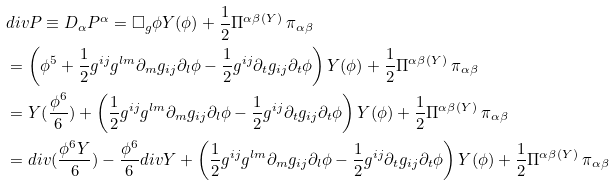<formula> <loc_0><loc_0><loc_500><loc_500>& d i v P \equiv D _ { \alpha } P ^ { \alpha } = \Box _ { g } \phi Y ( \phi ) + \frac { 1 } { 2 } \Pi ^ { \alpha \beta } { ^ { ( Y ) } \, \pi } _ { \alpha \beta } \\ & = \left ( \phi ^ { 5 } + \frac { 1 } { 2 } g ^ { i j } g ^ { l m } \partial _ { m } g _ { i j } \partial _ { l } \phi - \frac { 1 } { 2 } g ^ { i j } \partial _ { t } g _ { i j } \partial _ { t } \phi \right ) Y ( \phi ) + \frac { 1 } { 2 } \Pi ^ { \alpha \beta } { ^ { ( Y ) } \, \pi } _ { \alpha \beta } \\ & = Y ( \frac { \phi ^ { 6 } } { 6 } ) + \left ( \frac { 1 } { 2 } g ^ { i j } g ^ { l m } \partial _ { m } g _ { i j } \partial _ { l } \phi - \frac { 1 } { 2 } g ^ { i j } \partial _ { t } g _ { i j } \partial _ { t } \phi \right ) Y ( \phi ) + \frac { 1 } { 2 } \Pi ^ { \alpha \beta } { ^ { ( Y ) } \, \pi } _ { \alpha \beta } \\ & = d i v ( \frac { \phi ^ { 6 } Y } { 6 } ) - \frac { \phi ^ { 6 } } { 6 } d i v Y + \left ( \frac { 1 } { 2 } g ^ { i j } g ^ { l m } \partial _ { m } g _ { i j } \partial _ { l } \phi - \frac { 1 } { 2 } g ^ { i j } \partial _ { t } g _ { i j } \partial _ { t } \phi \right ) Y ( \phi ) + \frac { 1 } { 2 } \Pi ^ { \alpha \beta } { ^ { ( Y ) } \, \pi } _ { \alpha \beta } \\</formula> 